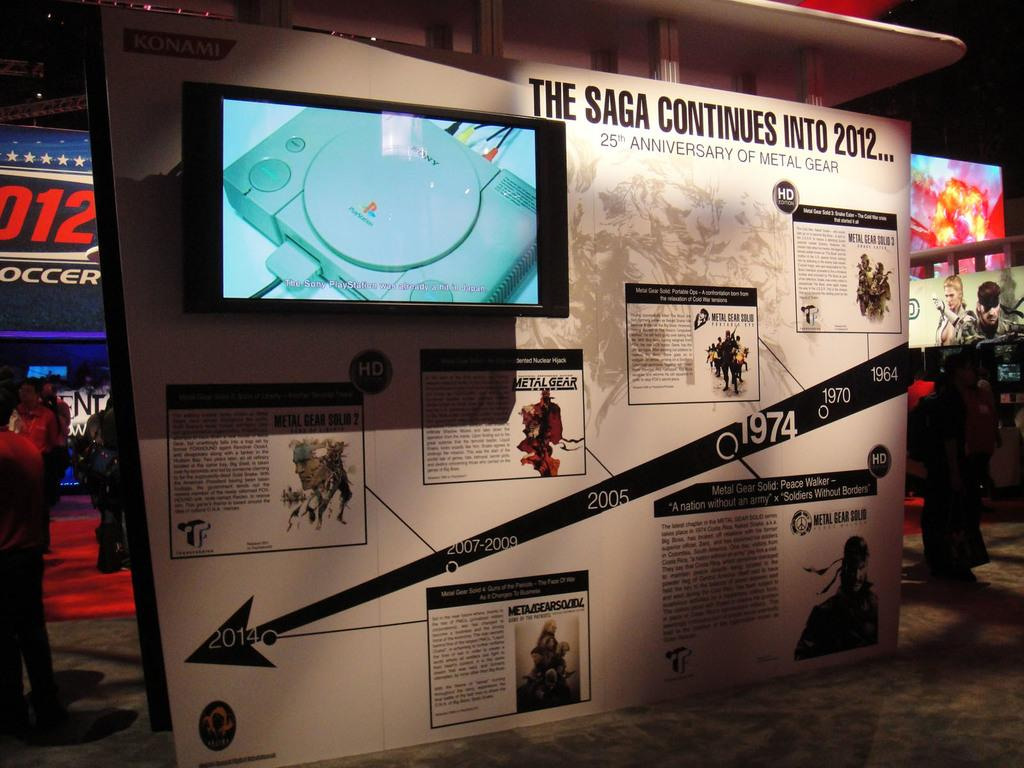Provide a one-sentence caption for the provided image. A timeline display celebrates 25 years of Metal Gear. 